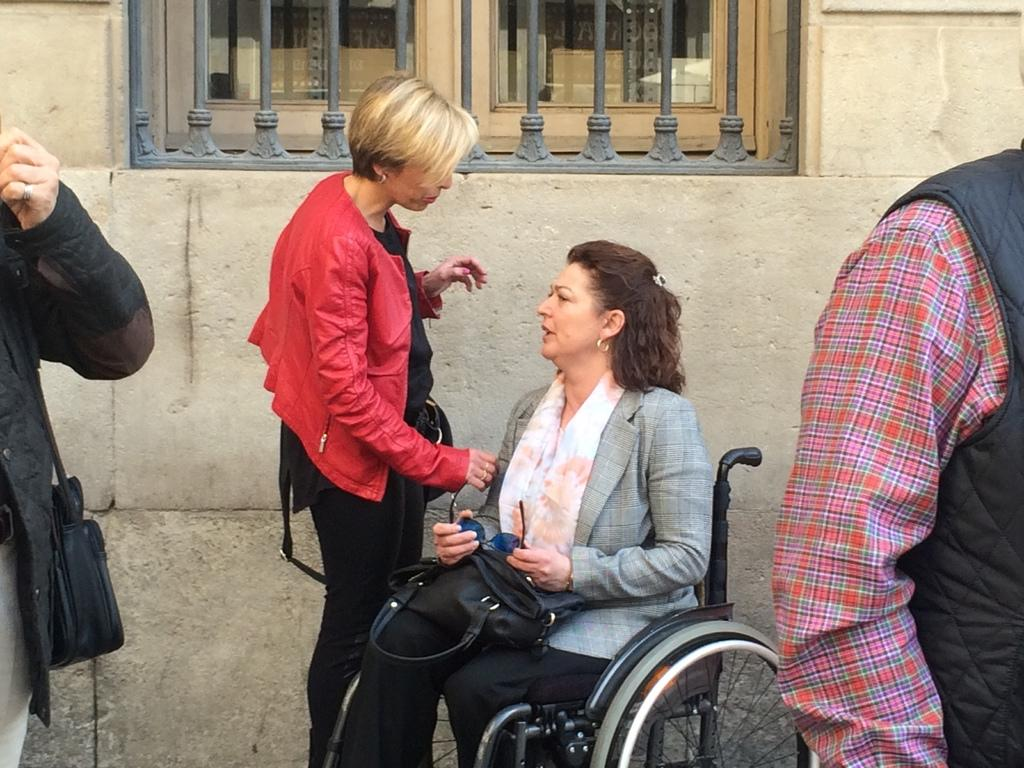What is the woman in the image using to move around? The woman is sitting on a wheelchair in the image. What are the other people in the image doing? There are people standing in the image. What can be seen behind the woman and people? There is a wall visible in the image. Is there any natural light coming into the room? Yes, there is a window in the image. What type of drain can be seen in the image? There is no drain present in the image. 